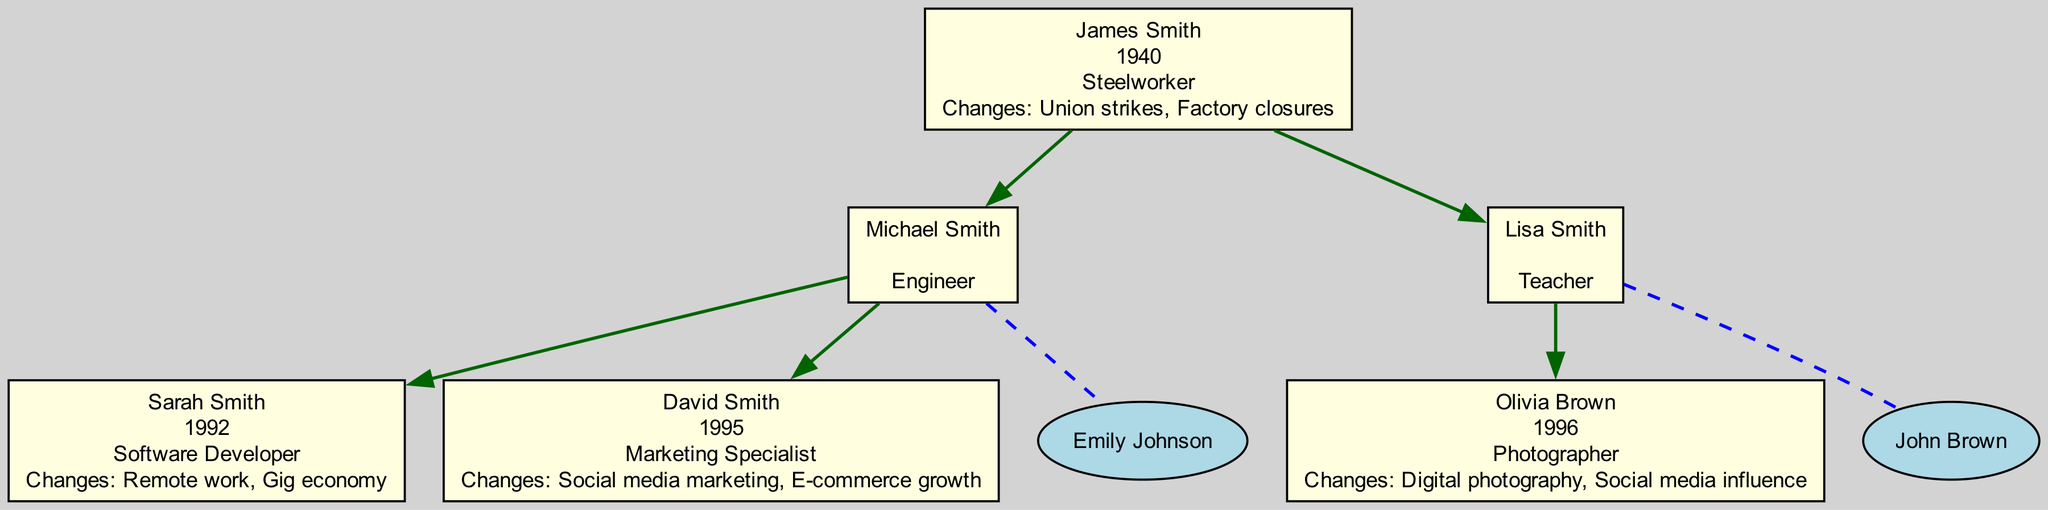What is the career of James Smith? The career of James Smith is stated in the diagram as "Steelworker." He is the first individual in the family tree and has this information included directly in his node.
Answer: Steelworker Who is the partner of Lisa Smith? Lisa Smith's partner is listed in the diagram as "John Brown." This relationship is indicated by a dashed line connecting the two nodes in the family tree.
Answer: John Brown How many children does Michael Smith have? Michael Smith has two children, Sarah Smith and David Smith, as depicted in the diagram with lines connecting him to these two nodes.
Answer: 2 What changes impacted Sarah Smith's career? The changes that impacted Sarah Smith's career are "Remote work, Gig economy." This information is included in her node as part of her career details.
Answer: Remote work, Gig economy Which career is associated with Olivia Brown? The career associated with Olivia Brown is "Photographer," as shown in the diagram corresponding to her node.
Answer: Photographer Where does Lisa Smith's career fit in the generational timeline? Lisa Smith's career as a Teacher fits into the timeline as the second generation (born in 1968) after James Smith (the first generation, born in 1940). This generational placement is determined by her being the child of James Smith.
Answer: Second generation What significant changes did James Smith experience in his career? James Smith experienced significant changes such as "Union strikes" and "Factory closures." These changes are outlined in his node, reflecting challenges during his career as a steelworker.
Answer: Union strikes, Factory closures Who are the children of Michael Smith? The children of Michael Smith are named "Sarah Smith" and "David Smith," shown as connected nodes underneath Michael Smith in the family tree.
Answer: Sarah Smith, David Smith What generational career change does David Smith represent? David Smith represents a career change to "Marketing Specialist" in the third generation, distinguishing him from the more traditional careers of his father and grandfather. This is inferred from his career placement compared to those of the previous generations.
Answer: Marketing Specialist 